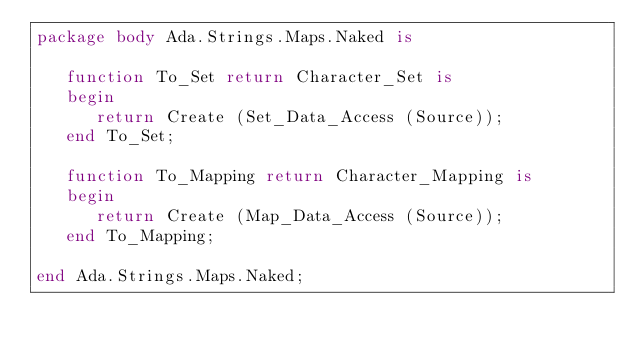Convert code to text. <code><loc_0><loc_0><loc_500><loc_500><_Ada_>package body Ada.Strings.Maps.Naked is

   function To_Set return Character_Set is
   begin
      return Create (Set_Data_Access (Source));
   end To_Set;

   function To_Mapping return Character_Mapping is
   begin
      return Create (Map_Data_Access (Source));
   end To_Mapping;

end Ada.Strings.Maps.Naked;
</code> 